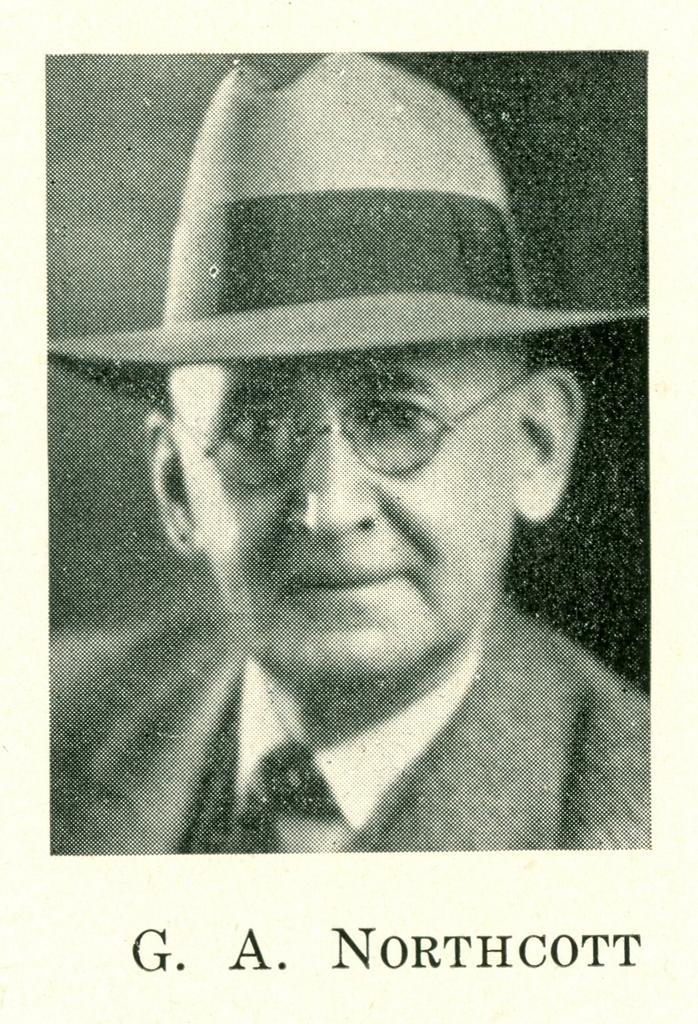Describe this image in one or two sentences. In this image we can see a photograph which includes one person and some written text at the bottom. 